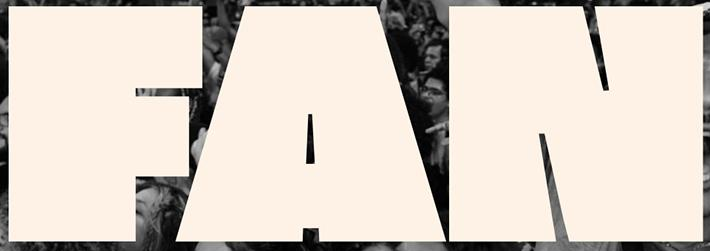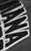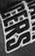What words can you see in these images in sequence, separated by a semicolon? FAN; IANA; CERS 